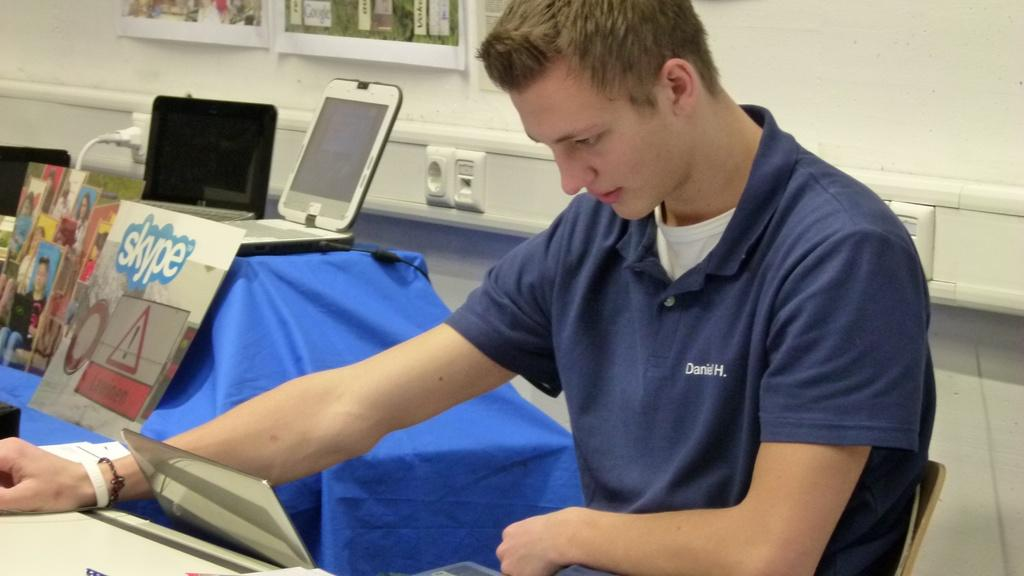Provide a one-sentence caption for the provided image. A man with Daniel H. stitched into his shirt. 